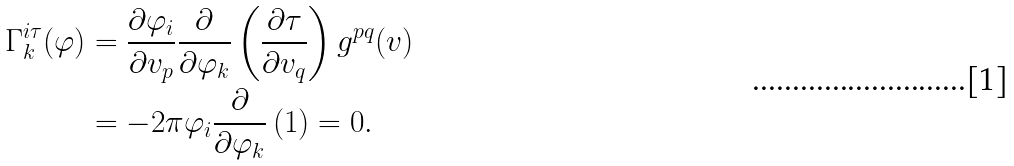<formula> <loc_0><loc_0><loc_500><loc_500>\Gamma _ { k } ^ { i \tau } ( \varphi ) & = \frac { \partial \varphi _ { i } } { \partial v _ { p } } \frac { \partial } { \partial \varphi _ { k } } \left ( \frac { \partial \tau } { \partial v _ { q } } \right ) g ^ { p q } ( v ) \\ & = - 2 \pi \varphi _ { i } \frac { \partial } { \partial \varphi _ { k } } \left ( 1 \right ) = 0 .</formula> 